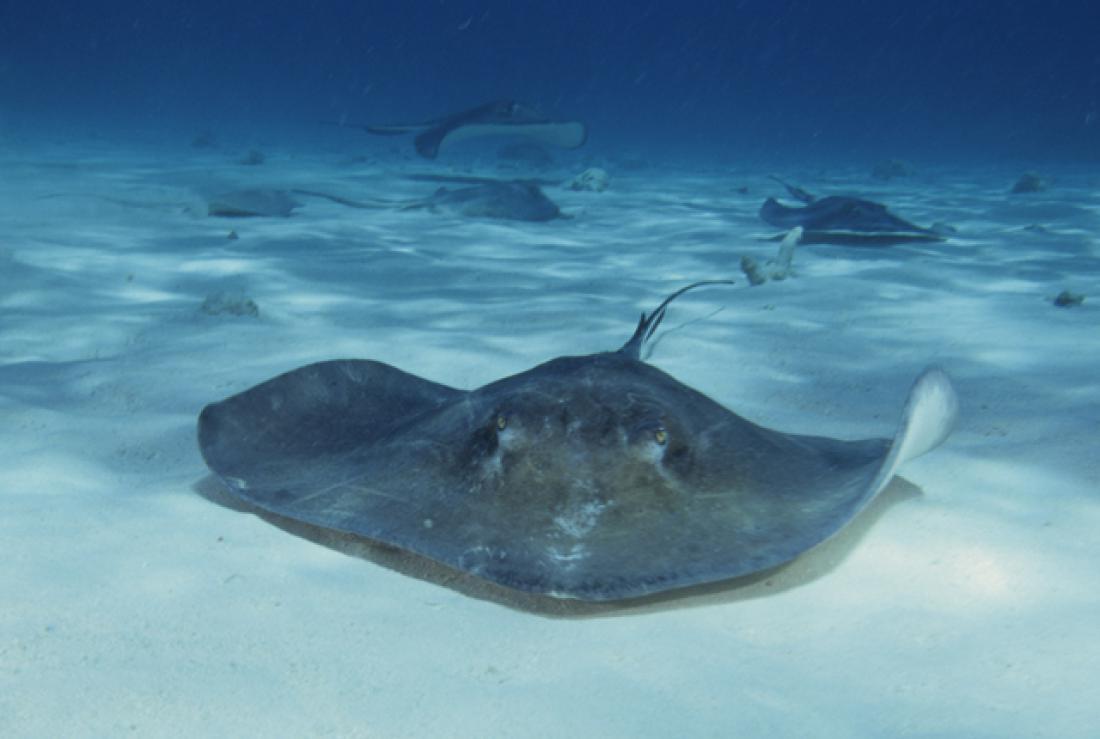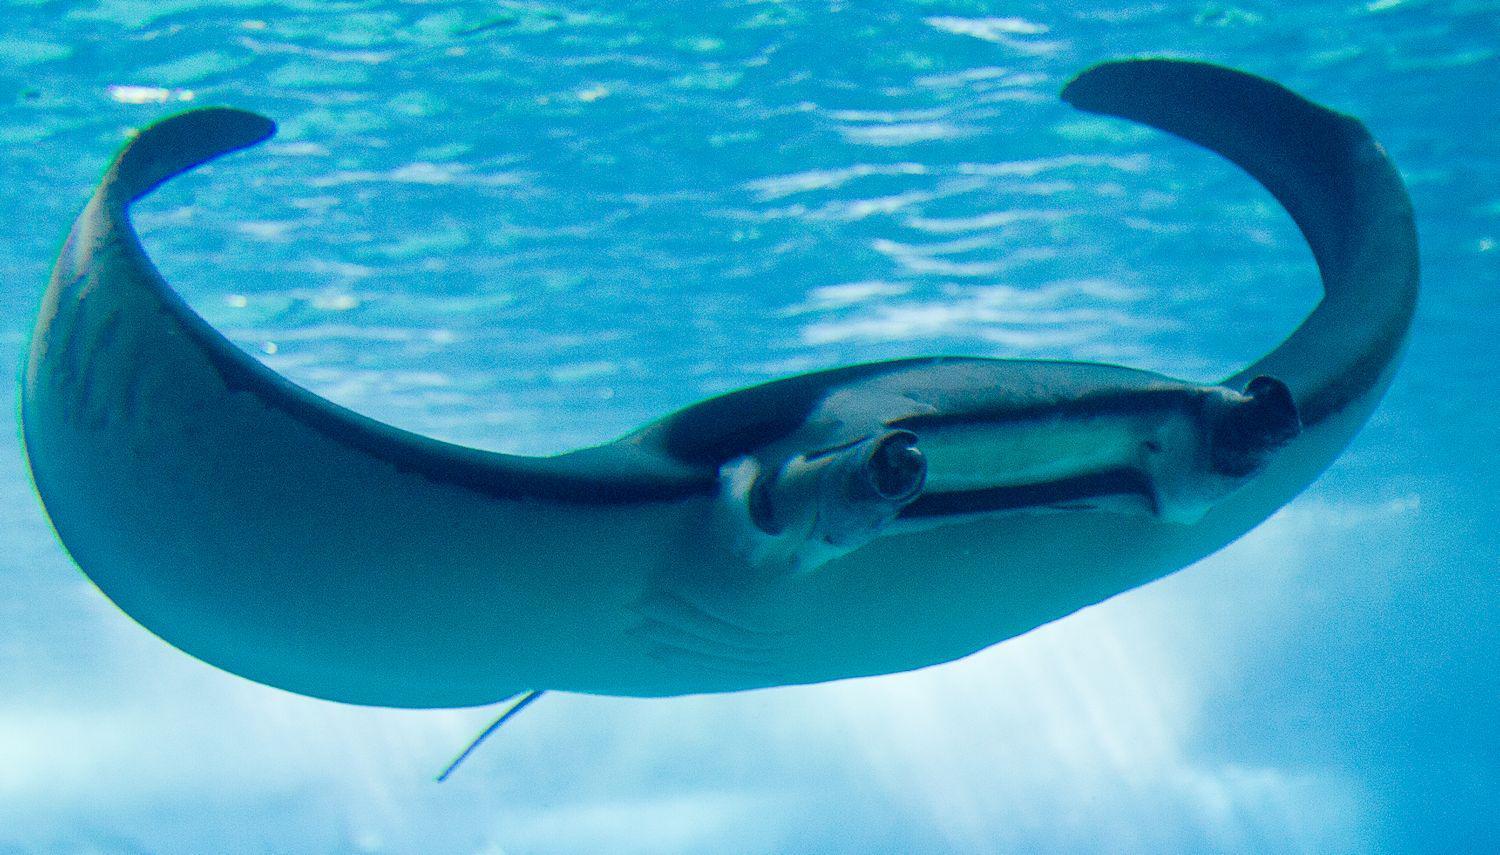The first image is the image on the left, the second image is the image on the right. For the images shown, is this caption "There is a scuba diver on one of the images." true? Answer yes or no. No. 